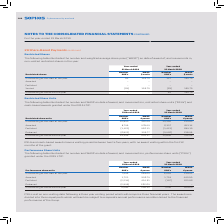According to Sophos Group's financial document, What is the  Outstanding at the start of the year  for 2019? According to the financial document, 7,546 (in thousands). The relevant text states: "Outstanding at the start of the year 7,546 269.65 6,024 219.41..." Also, Why are the PSU awards divided into three equal parts? The awards are divided into three equal parts which will each be subject to a separate annual performance condition linked to the financial performance of the Group.. The document states: "period which will comprise three financial years. The awards are divided into three equal parts which will each be subject to a separate annual perfor..." Also, What are the types of movements in performance share units (“PSUs”) illustrated in the table? The document contains multiple relevant values: Awarded, Forfeited, Released. From the document: "Forfeited (2,234) 414.51 (197) 223.96 Released (2,949) 262.64 – – Awarded 1,721 506.74 1,719 440.50..." Additionally, In which year was the number of PSUs awarded larger? According to the financial document, 2019. The relevant text states: "Year-ended 31 March 2019 Year-ended 31 March 2018..." Also, can you calculate: What was the change in the number of PSUs outstanding at the end of the year in 2019 from 2018? Based on the calculation: 4,084-7,546, the result is -3462 (in thousands). This is based on the information: "Outstanding at the end of the year 4,084 295.41 7,546 269.65 Outstanding at the end of the year 4,084 295.41 7,546 269.65..." The key data points involved are: 4,084, 7,546. Also, can you calculate: What was the percentage change in the number of PSUs outstanding at the end of the year in 2019 from 2018? To answer this question, I need to perform calculations using the financial data. The calculation is: (4,084-7,546)/7,546, which equals -45.88 (percentage). This is based on the information: "Outstanding at the end of the year 4,084 295.41 7,546 269.65 Outstanding at the end of the year 4,084 295.41 7,546 269.65..." The key data points involved are: 4,084, 7,546. 